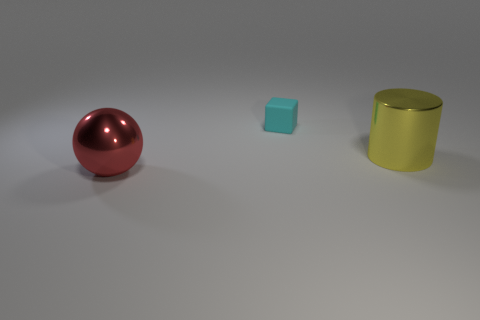Are there any other things that have the same size as the yellow cylinder?
Offer a very short reply. Yes. Do the big red thing and the small rubber thing have the same shape?
Offer a terse response. No. Are there fewer tiny things on the left side of the rubber object than yellow cylinders behind the yellow cylinder?
Your answer should be compact. No. There is a big yellow cylinder; what number of large shiny cylinders are in front of it?
Your answer should be very brief. 0. Does the large thing to the right of the big red object have the same shape as the thing that is to the left of the cyan object?
Provide a short and direct response. No. How many other things are there of the same color as the big shiny sphere?
Your answer should be compact. 0. What material is the object that is in front of the big yellow thing on the right side of the thing behind the big yellow shiny cylinder?
Your answer should be very brief. Metal. There is a large thing that is on the left side of the large thing that is right of the sphere; what is it made of?
Keep it short and to the point. Metal. Are there fewer red objects behind the matte block than big yellow objects?
Give a very brief answer. Yes. The thing that is on the left side of the small cyan cube has what shape?
Your answer should be very brief. Sphere. 